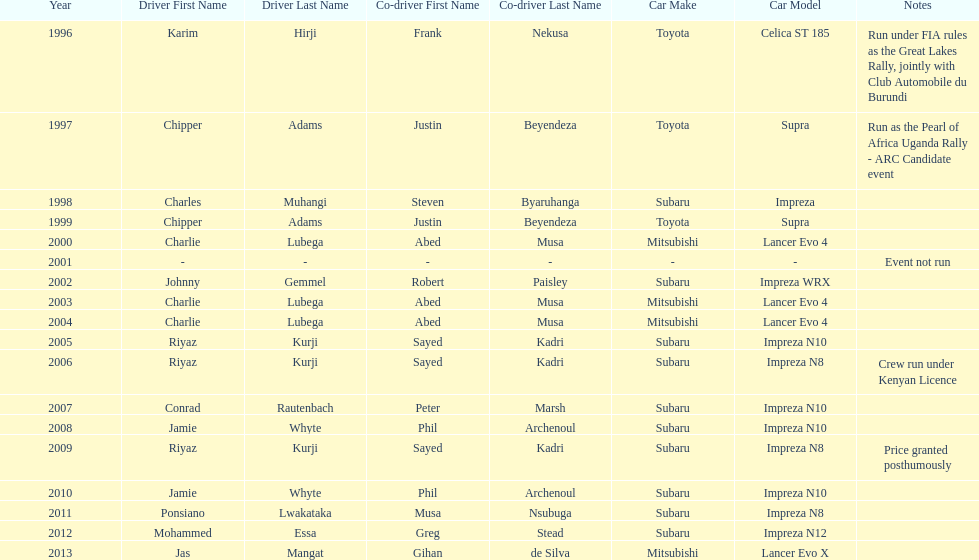Which driver won after ponsiano lwakataka? Mohammed Essa. 